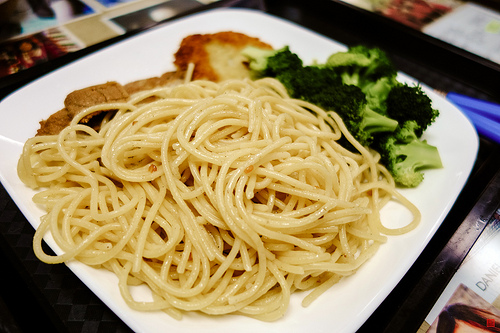<image>
Can you confirm if the noodles is in front of the plate? No. The noodles is not in front of the plate. The spatial positioning shows a different relationship between these objects. 